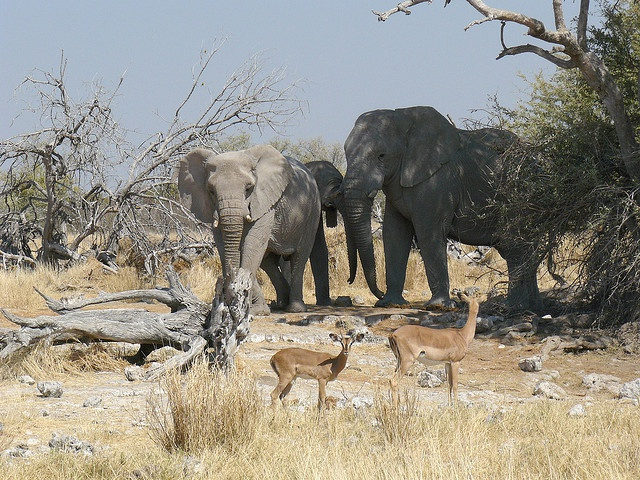Describe the objects in this image and their specific colors. I can see elephant in darkgray, black, gray, and purple tones, elephant in darkgray, gray, and black tones, and elephant in darkgray, black, and gray tones in this image. 